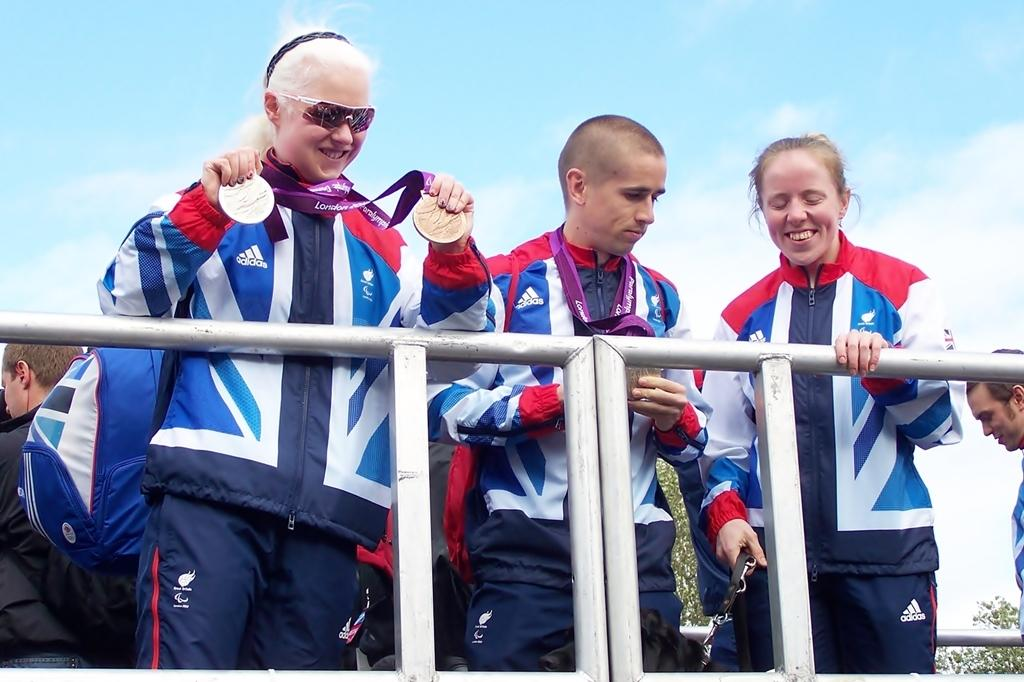What is happening in the image? There are people standing in the image. Can you describe any specific details about the people? Two of the people are wearing medals. What can be seen in the background of the image? There is a tree in the background of the image. What is visible at the top of the image? The sky is visible at the top of the image. What type of locket can be seen hanging from the tree in the image? There is no locket hanging from the tree in the image; it only features a tree in the background. Where is the lunchroom located in the image? There is no mention of a lunchroom in the image; it only shows people standing and a tree in the background. 